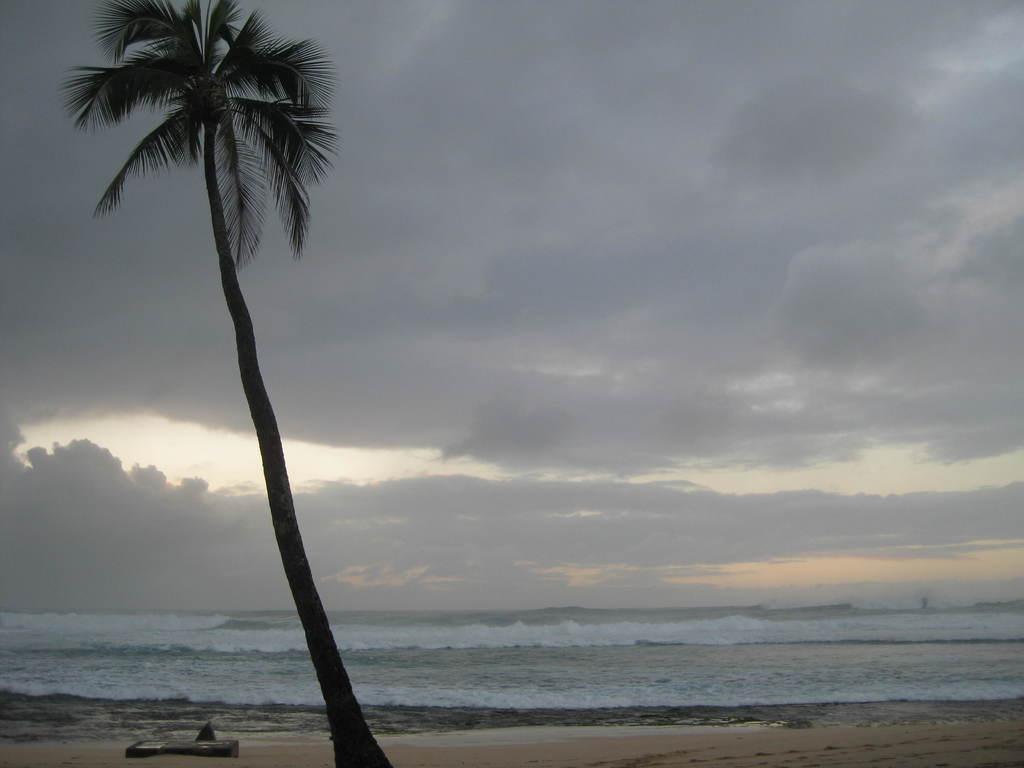In one or two sentences, can you explain what this image depicts? This image is taken outdoors. At the top of the image there is the sky with clouds. In the background there is a sea with waves. At the bottom of the image there is a ground. On the left side of the image there is a coconut tree. 